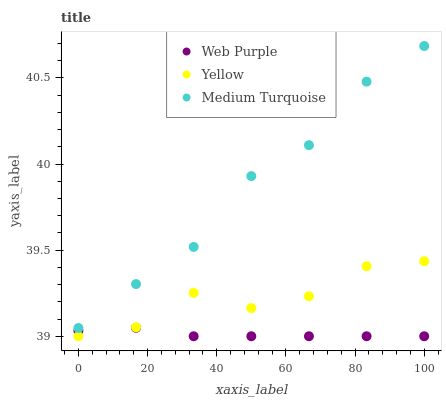Does Web Purple have the minimum area under the curve?
Answer yes or no. Yes. Does Medium Turquoise have the maximum area under the curve?
Answer yes or no. Yes. Does Yellow have the minimum area under the curve?
Answer yes or no. No. Does Yellow have the maximum area under the curve?
Answer yes or no. No. Is Web Purple the smoothest?
Answer yes or no. Yes. Is Yellow the roughest?
Answer yes or no. Yes. Is Medium Turquoise the smoothest?
Answer yes or no. No. Is Medium Turquoise the roughest?
Answer yes or no. No. Does Web Purple have the lowest value?
Answer yes or no. Yes. Does Medium Turquoise have the lowest value?
Answer yes or no. No. Does Medium Turquoise have the highest value?
Answer yes or no. Yes. Does Yellow have the highest value?
Answer yes or no. No. Is Web Purple less than Medium Turquoise?
Answer yes or no. Yes. Is Medium Turquoise greater than Yellow?
Answer yes or no. Yes. Does Yellow intersect Web Purple?
Answer yes or no. Yes. Is Yellow less than Web Purple?
Answer yes or no. No. Is Yellow greater than Web Purple?
Answer yes or no. No. Does Web Purple intersect Medium Turquoise?
Answer yes or no. No. 